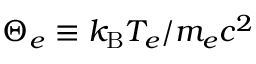Convert formula to latex. <formula><loc_0><loc_0><loc_500><loc_500>\Theta _ { e } \equiv k _ { B } T _ { e } / m _ { e } c ^ { 2 }</formula> 